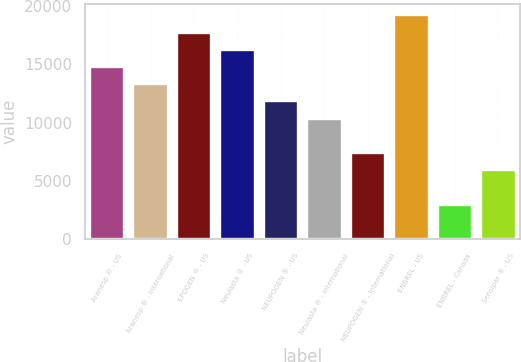Convert chart. <chart><loc_0><loc_0><loc_500><loc_500><bar_chart><fcel>Aranesp ® - US<fcel>Aranesp ® - International<fcel>EPOGEN ® - US<fcel>Neulasta ® - US<fcel>NEUPOGEN ® - US<fcel>Neulasta ® - International<fcel>NEUPOGEN ® - International<fcel>ENBREL - US<fcel>ENBREL - Canada<fcel>Sensipar ® - US<nl><fcel>14771<fcel>13297.4<fcel>17718.2<fcel>16244.6<fcel>11823.8<fcel>10350.2<fcel>7403<fcel>19191.8<fcel>2982.2<fcel>5929.4<nl></chart> 